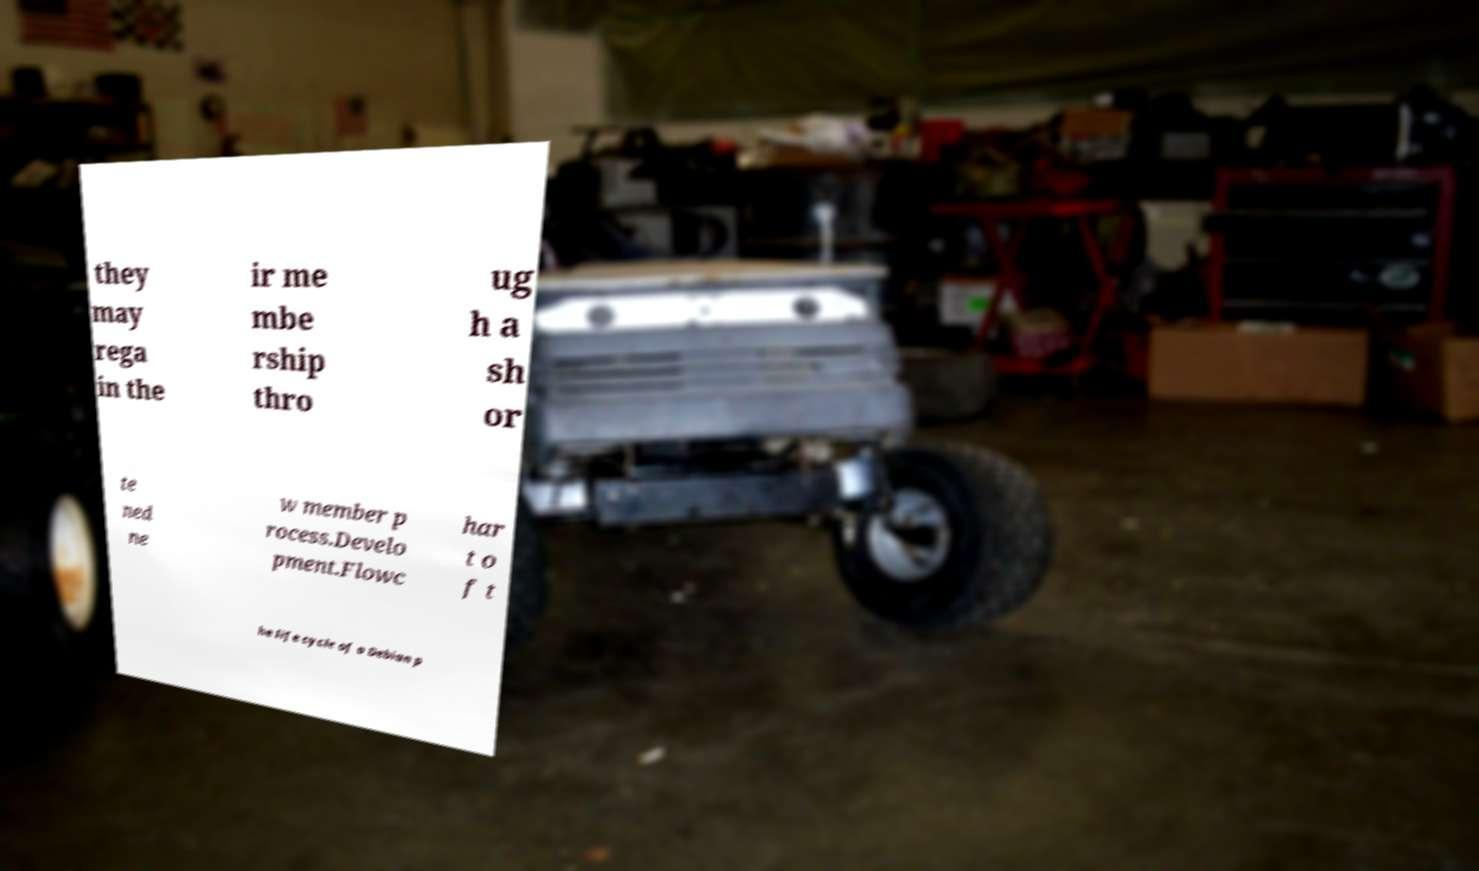What messages or text are displayed in this image? I need them in a readable, typed format. they may rega in the ir me mbe rship thro ug h a sh or te ned ne w member p rocess.Develo pment.Flowc har t o f t he life cycle of a Debian p 